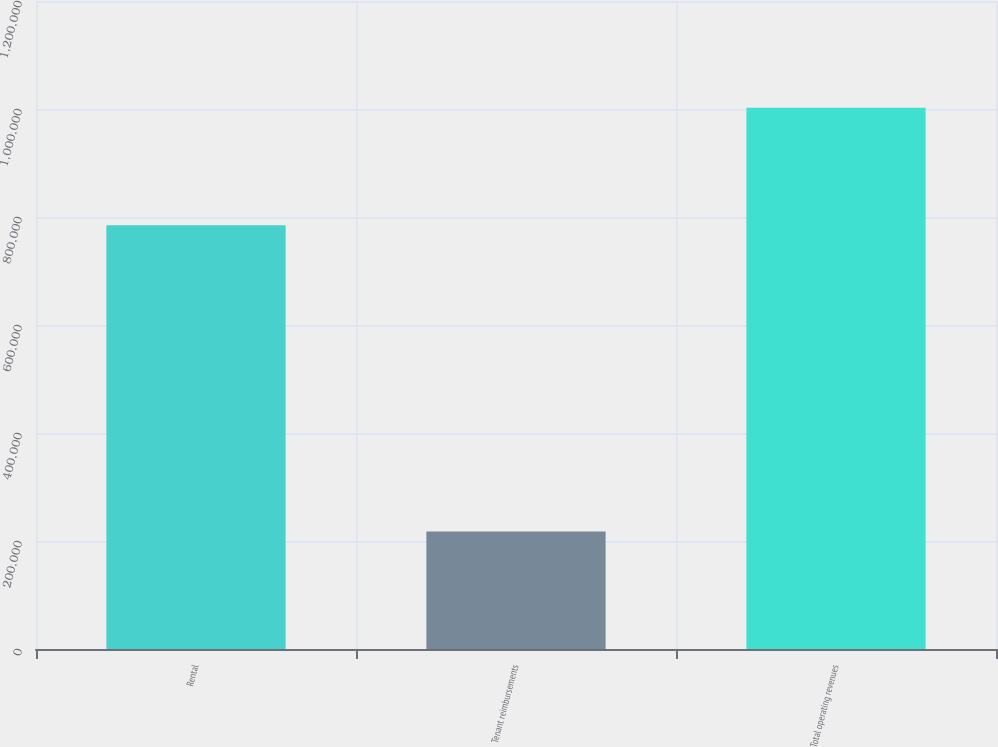<chart> <loc_0><loc_0><loc_500><loc_500><bar_chart><fcel>Rental<fcel>Tenant reimbursements<fcel>Total operating revenues<nl><fcel>784946<fcel>217484<fcel>1.00243e+06<nl></chart> 